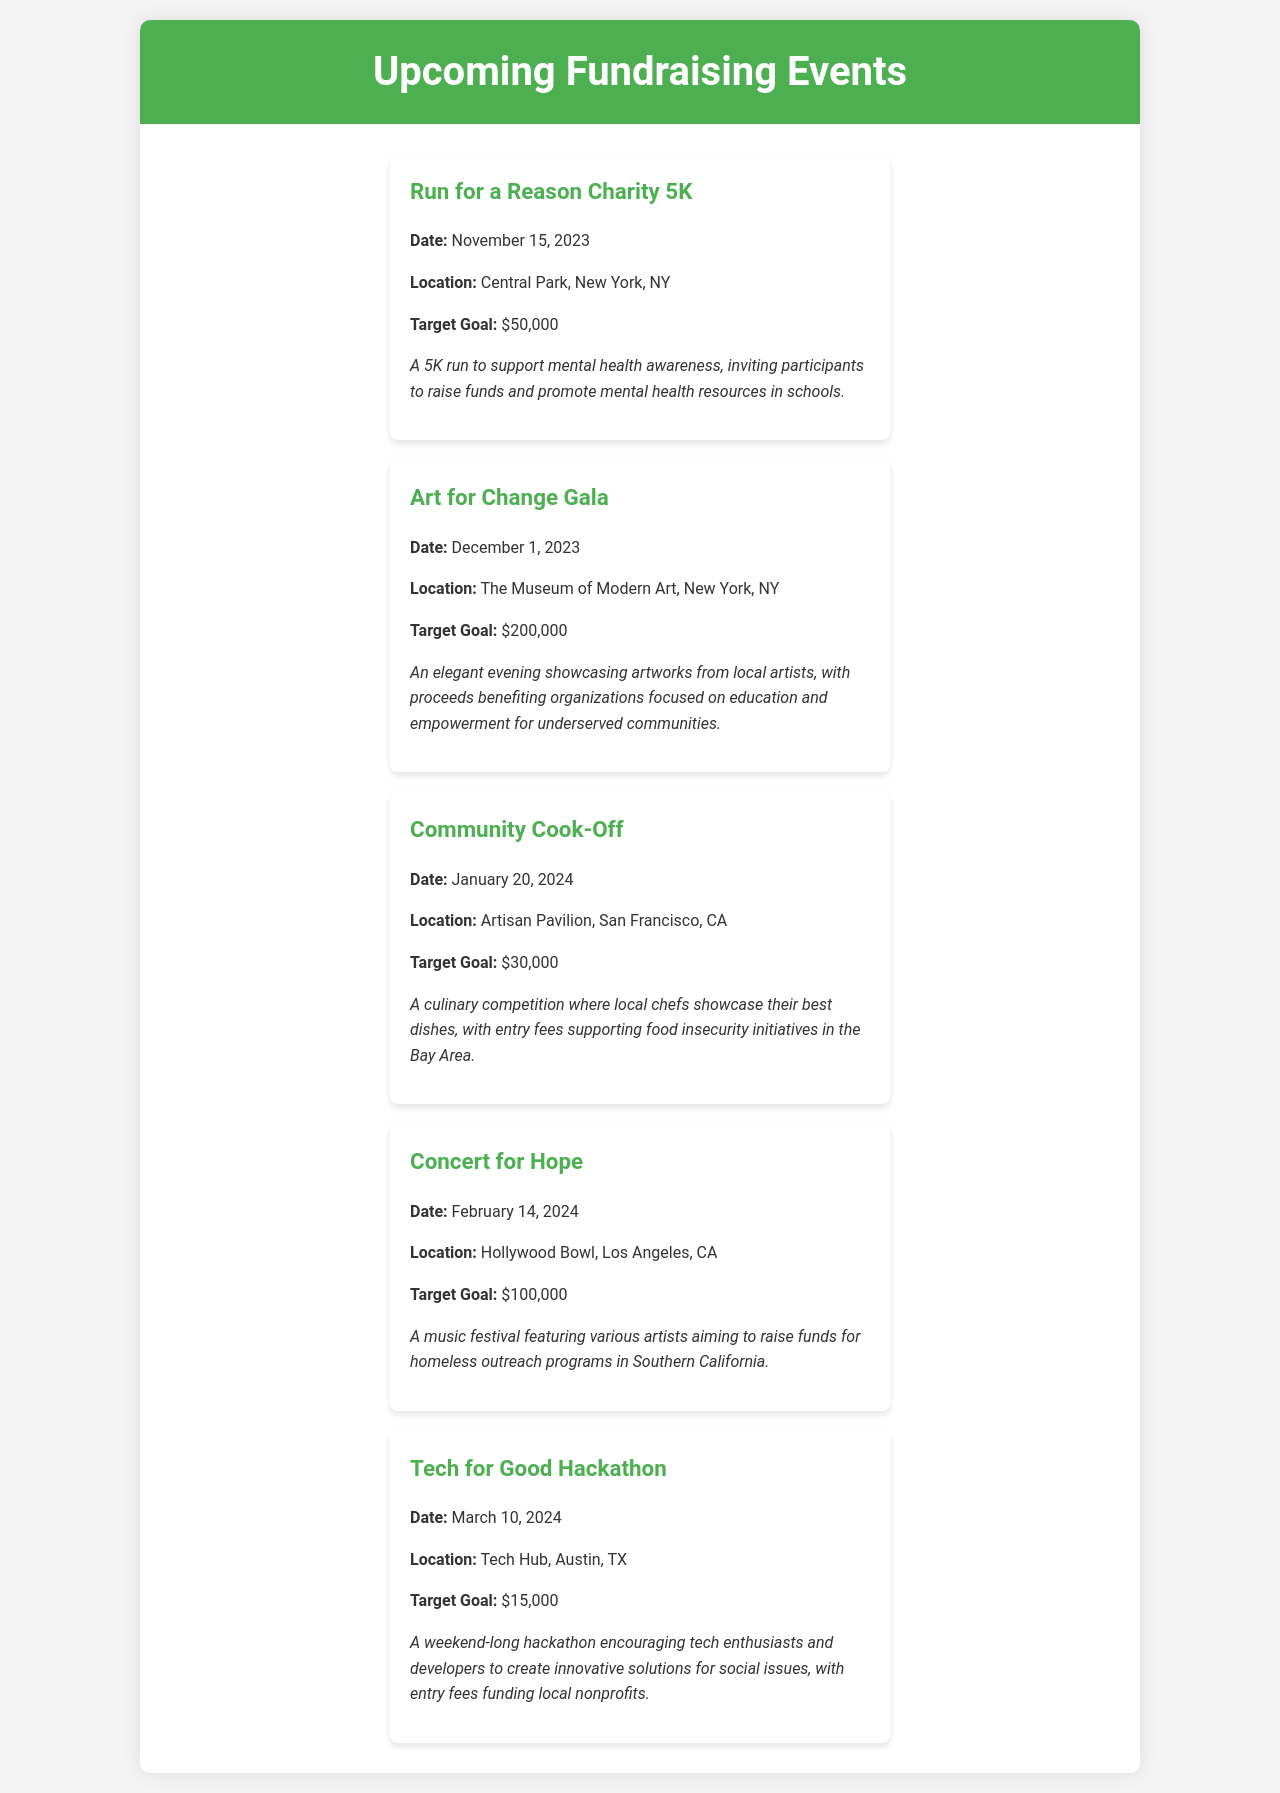What is the date of the Run for a Reason Charity 5K? The date listed for the Run for a Reason Charity 5K event is November 15, 2023.
Answer: November 15, 2023 Where will the Art for Change Gala take place? The document states that the Art for Change Gala will be held at The Museum of Modern Art, New York, NY.
Answer: The Museum of Modern Art, New York, NY What is the fundraising goal for the Community Cook-Off? The target fundraising goal for the Community Cook-Off event is specified as $30,000.
Answer: $30,000 Which event is scheduled for February 14, 2024? According to the schedule, the event taking place on February 14, 2024, is the Concert for Hope.
Answer: Concert for Hope How much total target fundraising is planned for all events? The total target fundraising is the sum of all individual event goals: $50,000 + $200,000 + $30,000 + $100,000 + $15,000 = $395,000.
Answer: $395,000 What type of event is the Tech for Good Hackathon? The Tech for Good Hackathon is described as a weekend-long hackathon focused on social issues.
Answer: Hackathon What is the location of the Concert for Hope? The document specifies that the location for the Concert for Hope is Hollywood Bowl, Los Angeles, CA.
Answer: Hollywood Bowl, Los Angeles, CA Which event aims to support mental health awareness? The Run for a Reason Charity 5K event focuses on supporting mental health awareness.
Answer: Run for a Reason Charity 5K 